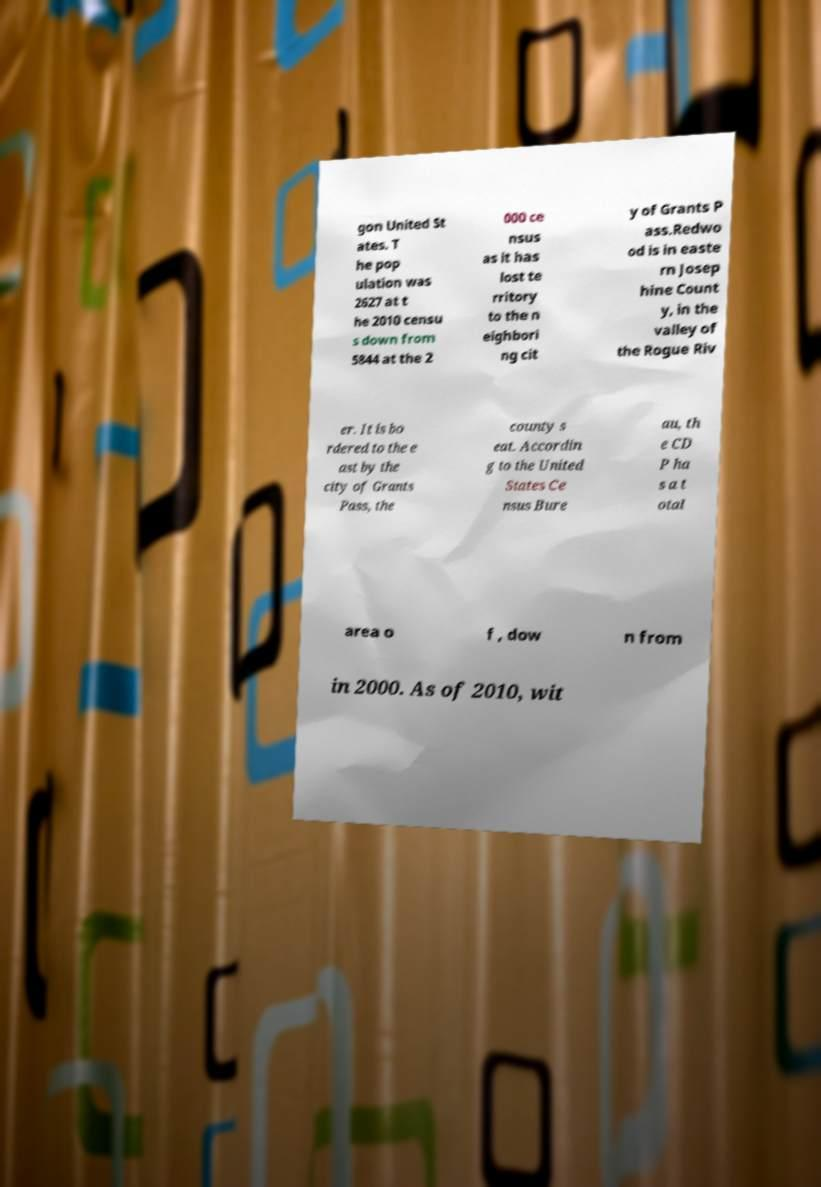Could you assist in decoding the text presented in this image and type it out clearly? gon United St ates. T he pop ulation was 2627 at t he 2010 censu s down from 5844 at the 2 000 ce nsus as it has lost te rritory to the n eighbori ng cit y of Grants P ass.Redwo od is in easte rn Josep hine Count y, in the valley of the Rogue Riv er. It is bo rdered to the e ast by the city of Grants Pass, the county s eat. Accordin g to the United States Ce nsus Bure au, th e CD P ha s a t otal area o f , dow n from in 2000. As of 2010, wit 